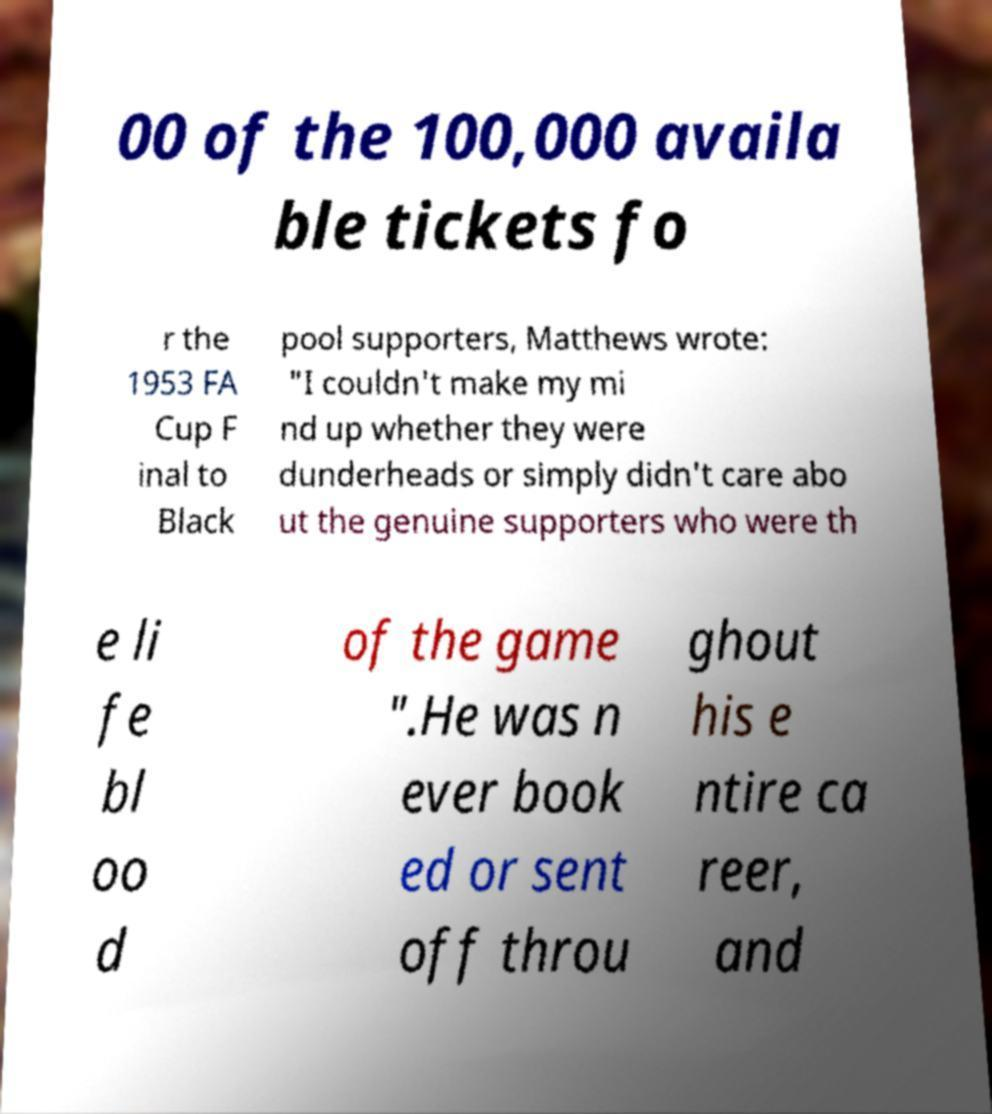Can you accurately transcribe the text from the provided image for me? 00 of the 100,000 availa ble tickets fo r the 1953 FA Cup F inal to Black pool supporters, Matthews wrote: "I couldn't make my mi nd up whether they were dunderheads or simply didn't care abo ut the genuine supporters who were th e li fe bl oo d of the game ".He was n ever book ed or sent off throu ghout his e ntire ca reer, and 